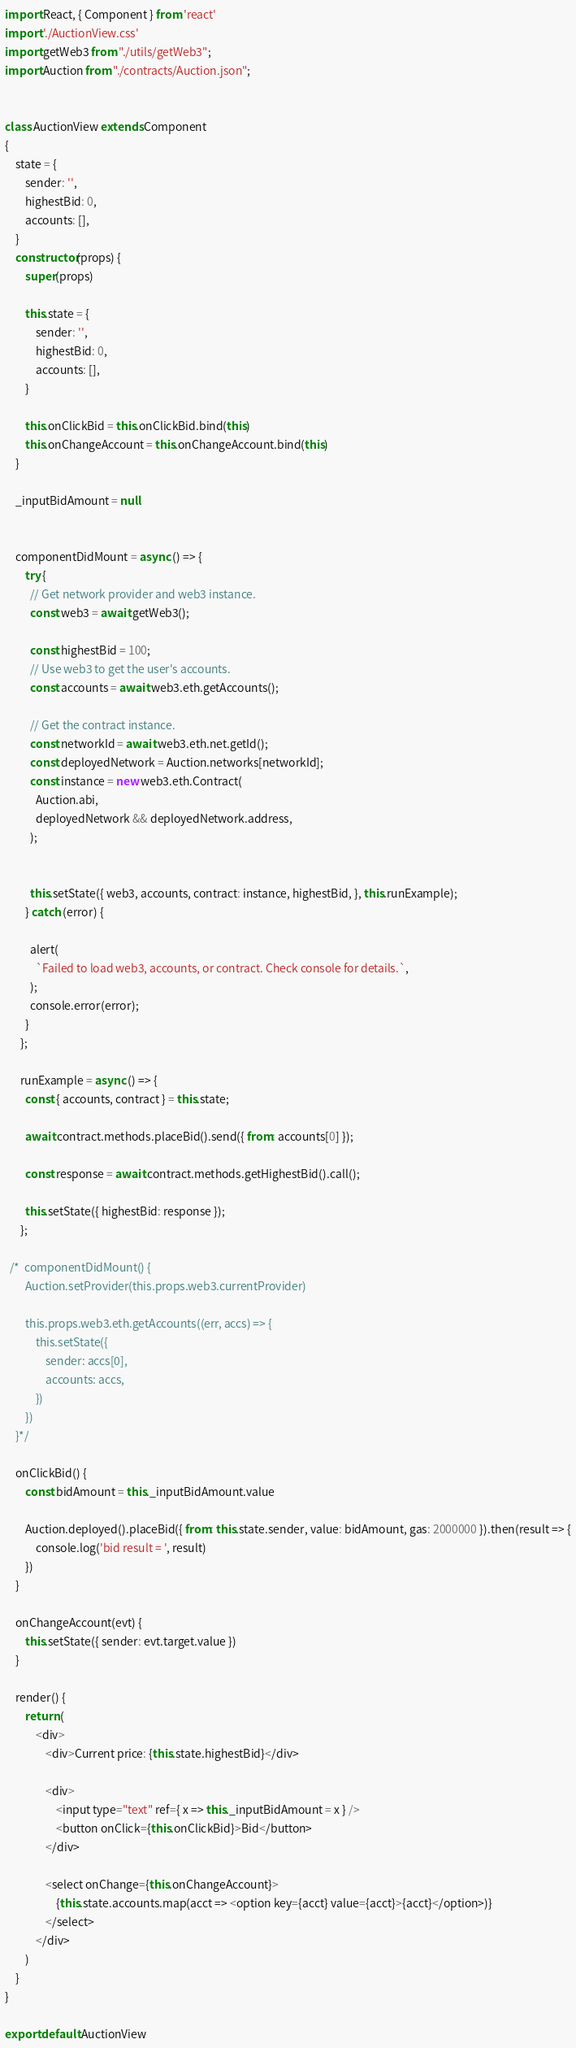Convert code to text. <code><loc_0><loc_0><loc_500><loc_500><_JavaScript_>import React, { Component } from 'react'
import './AuctionView.css'
import getWeb3 from "./utils/getWeb3";
import Auction from "./contracts/Auction.json";


class AuctionView extends Component
{
    state = {
        sender: '',
        highestBid: 0,
        accounts: [],
    }
    constructor(props) {
        super(props)

        this.state = {
            sender: '',
            highestBid: 0,
            accounts: [],
        }

        this.onClickBid = this.onClickBid.bind(this)
        this.onChangeAccount = this.onChangeAccount.bind(this)
    }

    _inputBidAmount = null

    
    componentDidMount = async () => {
        try {
          // Get network provider and web3 instance.
          const web3 = await getWeb3();
          
          const highestBid = 100;
          // Use web3 to get the user's accounts.
          const accounts = await web3.eth.getAccounts();
    
          // Get the contract instance.
          const networkId = await web3.eth.net.getId();
          const deployedNetwork = Auction.networks[networkId];
          const instance = new web3.eth.Contract(
            Auction.abi,
            deployedNetwork && deployedNetwork.address,
          );

    
          this.setState({ web3, accounts, contract: instance, highestBid, }, this.runExample);
        } catch (error) {
    
          alert(
            `Failed to load web3, accounts, or contract. Check console for details.`,
          );
          console.error(error);
        }
      };
  
      runExample = async () => {
        const { accounts, contract } = this.state;
    
        await contract.methods.placeBid().send({ from: accounts[0] });
  
        const response = await contract.methods.getHighestBid().call();
  
        this.setState({ highestBid: response });
      };

  /*  componentDidMount() {
        Auction.setProvider(this.props.web3.currentProvider)

        this.props.web3.eth.getAccounts((err, accs) => {
            this.setState({
                sender: accs[0],
                accounts: accs,
            })
        })
    }*/

    onClickBid() {
        const bidAmount = this._inputBidAmount.value

        Auction.deployed().placeBid({ from: this.state.sender, value: bidAmount, gas: 2000000 }).then(result => {
            console.log('bid result = ', result)
        })
    }

    onChangeAccount(evt) {
        this.setState({ sender: evt.target.value })
    }

    render() {
        return (
            <div>
                <div>Current price: {this.state.highestBid}</div>

                <div>
                    <input type="text" ref={ x => this._inputBidAmount = x } />
                    <button onClick={this.onClickBid}>Bid</button>
                </div>

                <select onChange={this.onChangeAccount}>
                    {this.state.accounts.map(acct => <option key={acct} value={acct}>{acct}</option>)}
                </select>
            </div>
        )
    }
}

export default AuctionView
</code> 